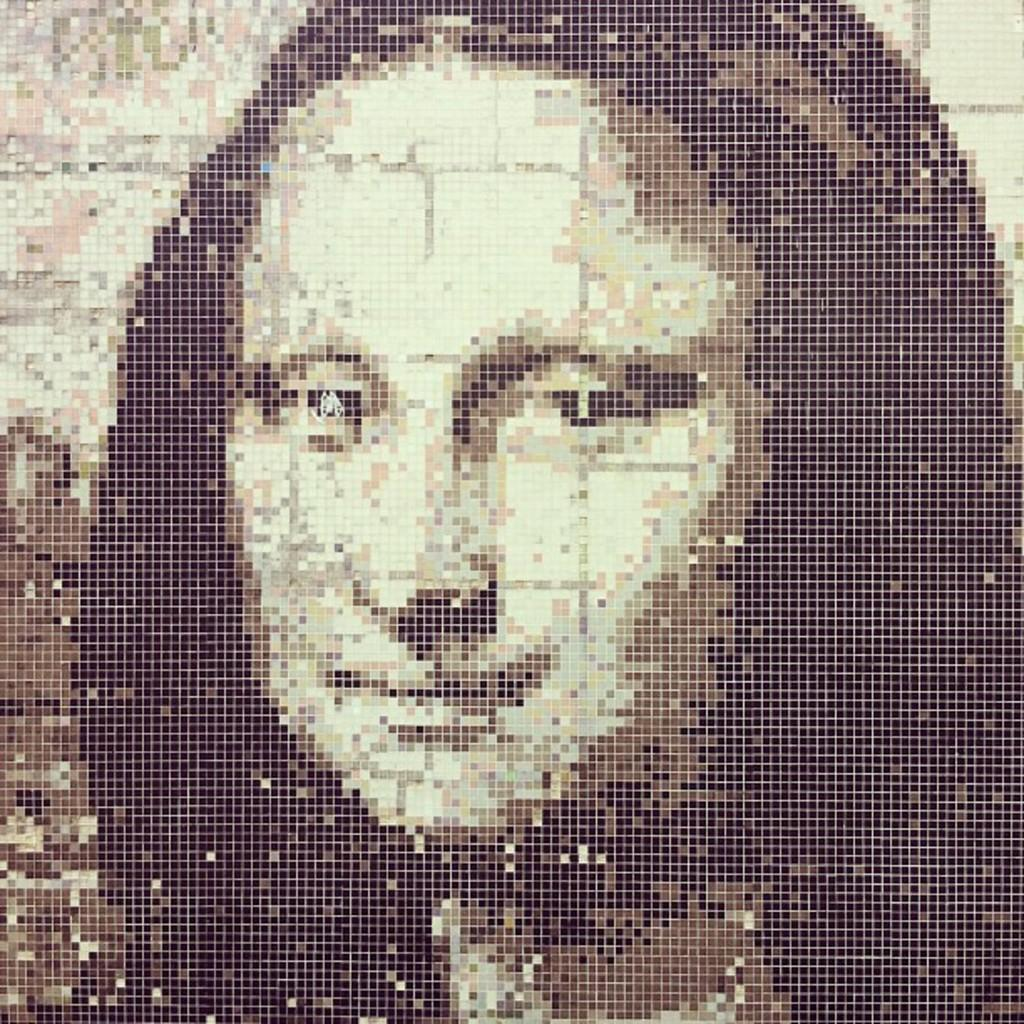What can be observed about the image's appearance? The image is edited. Who is present in the image? There is a woman in the image. What type of government is depicted in the image? There is no government depicted in the image; it features a woman. What is the woman using to hang the curtain in the image? There is no curtain present in the image, and therefore no need for a tool like a hammer. 